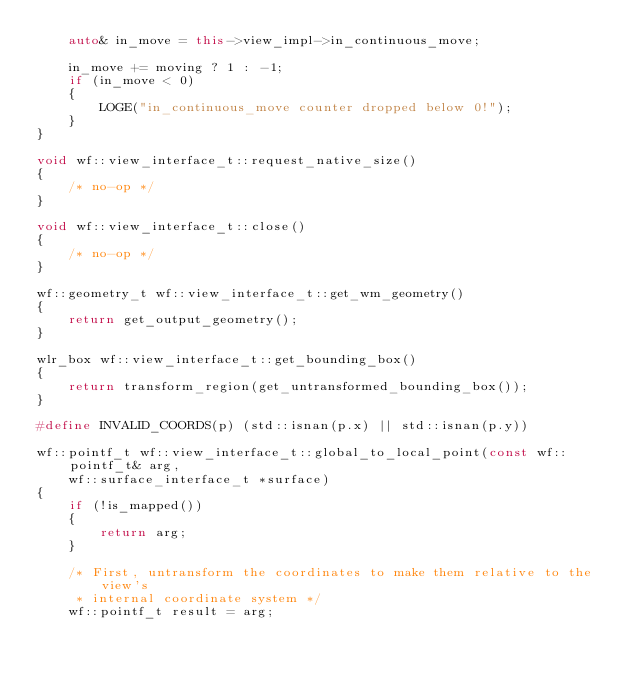<code> <loc_0><loc_0><loc_500><loc_500><_C++_>    auto& in_move = this->view_impl->in_continuous_move;

    in_move += moving ? 1 : -1;
    if (in_move < 0)
    {
        LOGE("in_continuous_move counter dropped below 0!");
    }
}

void wf::view_interface_t::request_native_size()
{
    /* no-op */
}

void wf::view_interface_t::close()
{
    /* no-op */
}

wf::geometry_t wf::view_interface_t::get_wm_geometry()
{
    return get_output_geometry();
}

wlr_box wf::view_interface_t::get_bounding_box()
{
    return transform_region(get_untransformed_bounding_box());
}

#define INVALID_COORDS(p) (std::isnan(p.x) || std::isnan(p.y))

wf::pointf_t wf::view_interface_t::global_to_local_point(const wf::pointf_t& arg,
    wf::surface_interface_t *surface)
{
    if (!is_mapped())
    {
        return arg;
    }

    /* First, untransform the coordinates to make them relative to the view's
     * internal coordinate system */
    wf::pointf_t result = arg;</code> 